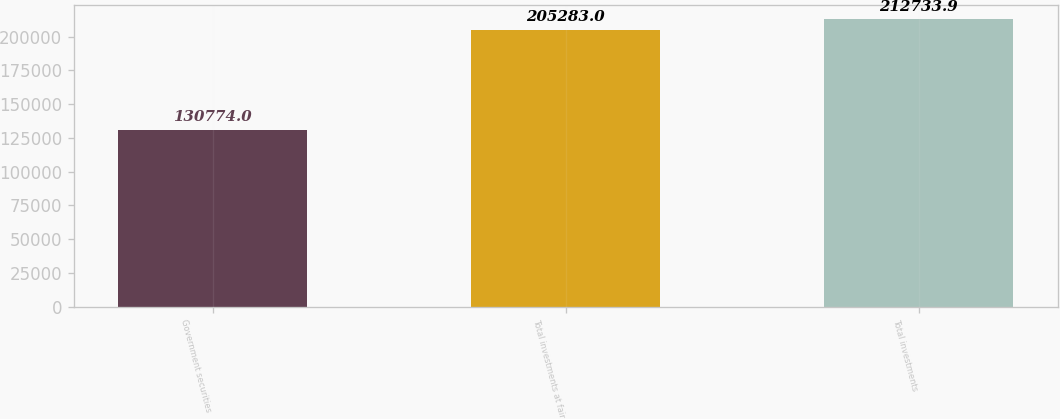<chart> <loc_0><loc_0><loc_500><loc_500><bar_chart><fcel>Government securities<fcel>Total investments at fair<fcel>Total investments<nl><fcel>130774<fcel>205283<fcel>212734<nl></chart> 